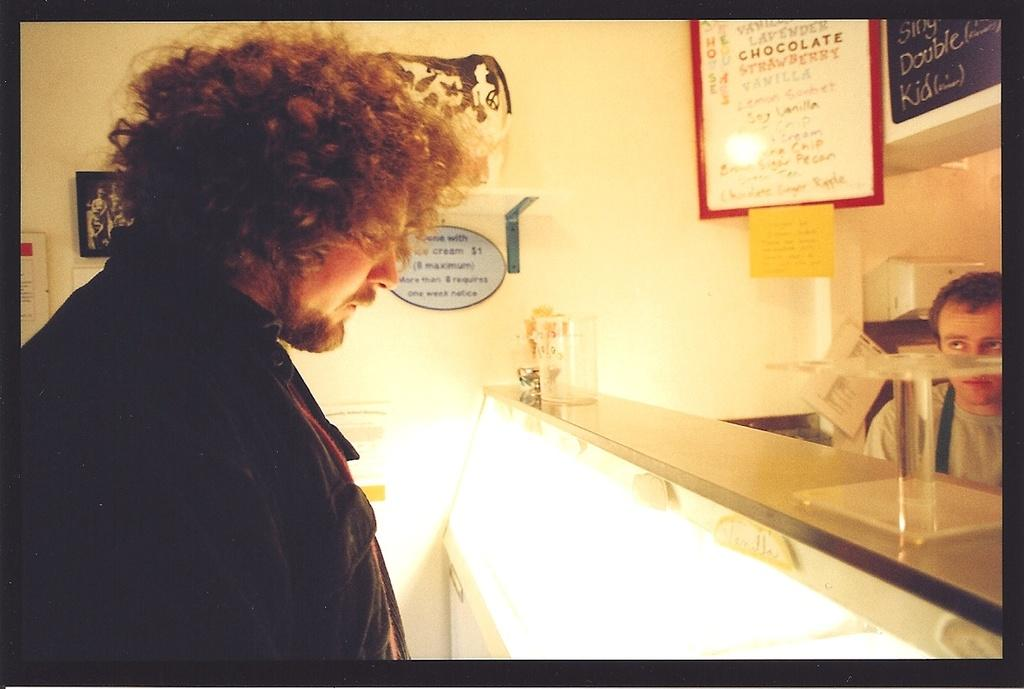Who or what can be seen in the image? There are people in the image. What is the purpose of the showcase in the image? The showcase is likely used for displaying objects or items. What are the boards in the image used for? The boards in the image may be used for signage, information, or decoration. What can be found on the wall in the image? There are objects on the wall in the image. Can you describe the objects in the image? There are objects in the image, but their specific nature cannot be determined from the provided facts. What type of rhythm is being played by the people in the image? There is no indication of music or rhythm in the image; it only shows people, a showcase, boards, and objects on the wall. 